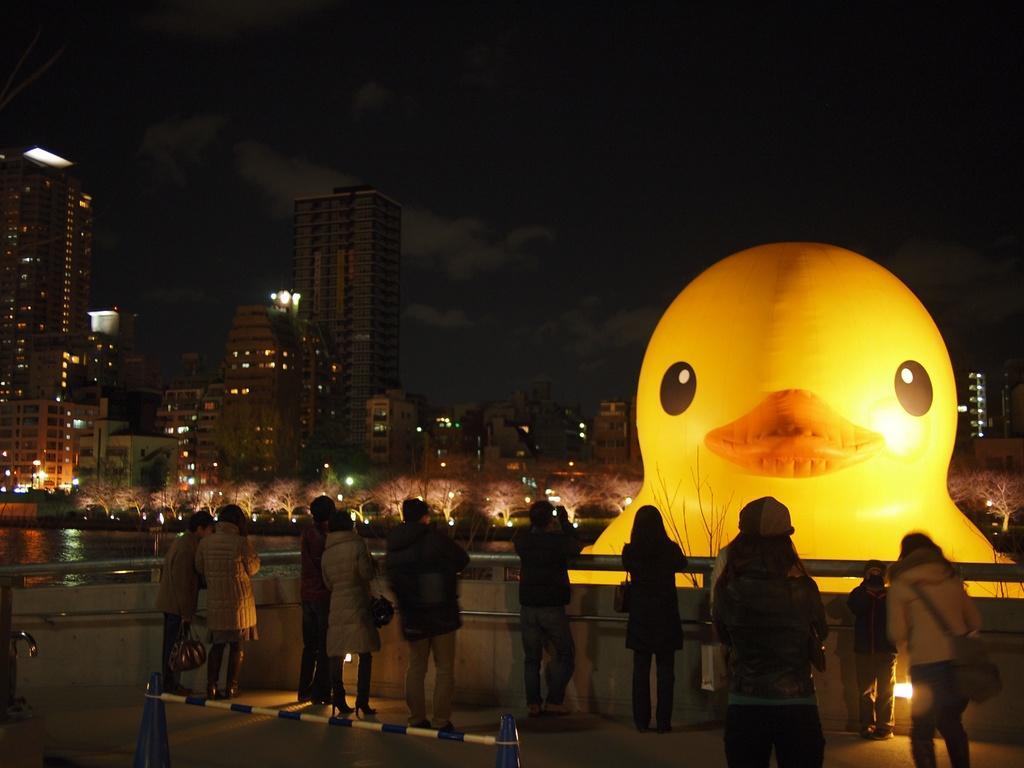How would you summarize this image in a sentence or two? In this image there are a few people standing and watching a balloon, in front of the people there is a lake, on the other side of the lake there are buildings. 